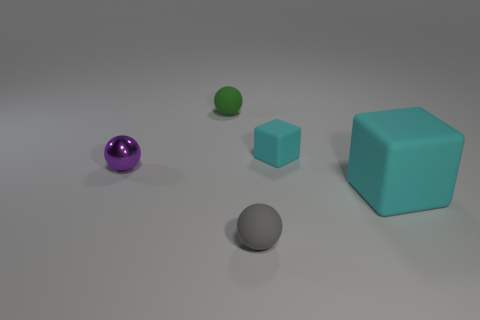Add 4 green matte balls. How many objects exist? 9 Add 3 large brown matte cylinders. How many large brown matte cylinders exist? 3 Subtract 0 brown blocks. How many objects are left? 5 Subtract all spheres. How many objects are left? 2 Subtract all yellow spheres. Subtract all tiny purple things. How many objects are left? 4 Add 2 large cubes. How many large cubes are left? 3 